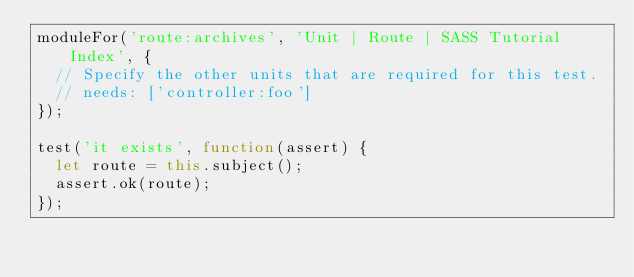Convert code to text. <code><loc_0><loc_0><loc_500><loc_500><_JavaScript_>moduleFor('route:archives', 'Unit | Route | SASS Tutorial Index', {
  // Specify the other units that are required for this test.
  // needs: ['controller:foo']
});

test('it exists', function(assert) {
  let route = this.subject();
  assert.ok(route);
});
</code> 